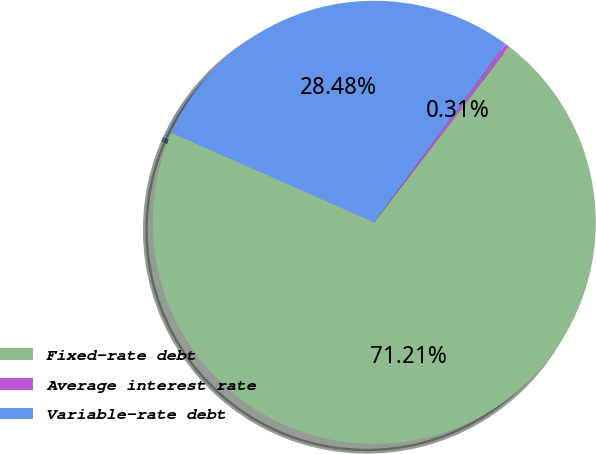Convert chart. <chart><loc_0><loc_0><loc_500><loc_500><pie_chart><fcel>Fixed-rate debt<fcel>Average interest rate<fcel>Variable-rate debt<nl><fcel>71.2%<fcel>0.31%<fcel>28.48%<nl></chart> 